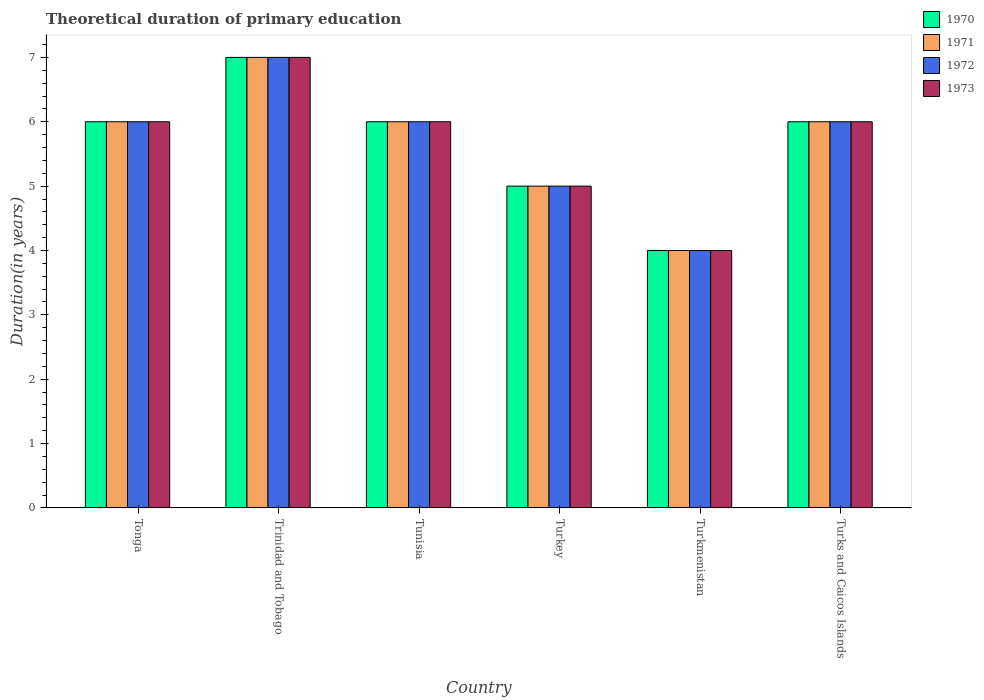How many groups of bars are there?
Ensure brevity in your answer.  6. Are the number of bars per tick equal to the number of legend labels?
Offer a very short reply. Yes. How many bars are there on the 1st tick from the left?
Keep it short and to the point. 4. How many bars are there on the 1st tick from the right?
Provide a short and direct response. 4. What is the label of the 1st group of bars from the left?
Your answer should be compact. Tonga. What is the total theoretical duration of primary education in 1970 in Trinidad and Tobago?
Give a very brief answer. 7. In which country was the total theoretical duration of primary education in 1971 maximum?
Your answer should be compact. Trinidad and Tobago. In which country was the total theoretical duration of primary education in 1971 minimum?
Offer a terse response. Turkmenistan. What is the total total theoretical duration of primary education in 1971 in the graph?
Ensure brevity in your answer.  34. What is the average total theoretical duration of primary education in 1971 per country?
Offer a terse response. 5.67. Is the total theoretical duration of primary education in 1971 in Tunisia less than that in Turks and Caicos Islands?
Provide a short and direct response. No. Is the difference between the total theoretical duration of primary education in 1973 in Trinidad and Tobago and Turkmenistan greater than the difference between the total theoretical duration of primary education in 1971 in Trinidad and Tobago and Turkmenistan?
Your answer should be compact. No. What is the difference between the highest and the second highest total theoretical duration of primary education in 1973?
Keep it short and to the point. -1. What is the difference between the highest and the lowest total theoretical duration of primary education in 1970?
Your answer should be very brief. 3. In how many countries, is the total theoretical duration of primary education in 1972 greater than the average total theoretical duration of primary education in 1972 taken over all countries?
Your answer should be compact. 4. What does the 2nd bar from the left in Tonga represents?
Provide a short and direct response. 1971. What does the 4th bar from the right in Turkey represents?
Give a very brief answer. 1970. Is it the case that in every country, the sum of the total theoretical duration of primary education in 1973 and total theoretical duration of primary education in 1972 is greater than the total theoretical duration of primary education in 1970?
Keep it short and to the point. Yes. How many bars are there?
Your response must be concise. 24. Does the graph contain any zero values?
Give a very brief answer. No. Does the graph contain grids?
Your answer should be very brief. No. How are the legend labels stacked?
Make the answer very short. Vertical. What is the title of the graph?
Make the answer very short. Theoretical duration of primary education. What is the label or title of the Y-axis?
Your response must be concise. Duration(in years). What is the Duration(in years) in 1972 in Tonga?
Provide a short and direct response. 6. What is the Duration(in years) in 1973 in Tonga?
Your answer should be very brief. 6. What is the Duration(in years) in 1970 in Trinidad and Tobago?
Give a very brief answer. 7. What is the Duration(in years) of 1971 in Trinidad and Tobago?
Ensure brevity in your answer.  7. What is the Duration(in years) in 1973 in Trinidad and Tobago?
Your answer should be compact. 7. What is the Duration(in years) in 1970 in Tunisia?
Your response must be concise. 6. What is the Duration(in years) of 1971 in Turkey?
Provide a short and direct response. 5. What is the Duration(in years) of 1972 in Turkey?
Your answer should be very brief. 5. What is the Duration(in years) of 1973 in Turkey?
Your answer should be very brief. 5. What is the Duration(in years) of 1971 in Turkmenistan?
Offer a very short reply. 4. What is the Duration(in years) in 1972 in Turkmenistan?
Your answer should be very brief. 4. What is the Duration(in years) in 1973 in Turkmenistan?
Provide a succinct answer. 4. What is the Duration(in years) in 1971 in Turks and Caicos Islands?
Give a very brief answer. 6. What is the Duration(in years) of 1973 in Turks and Caicos Islands?
Make the answer very short. 6. Across all countries, what is the maximum Duration(in years) of 1970?
Keep it short and to the point. 7. Across all countries, what is the maximum Duration(in years) of 1971?
Provide a short and direct response. 7. Across all countries, what is the minimum Duration(in years) in 1970?
Offer a very short reply. 4. Across all countries, what is the minimum Duration(in years) in 1972?
Your answer should be compact. 4. What is the total Duration(in years) of 1970 in the graph?
Provide a succinct answer. 34. What is the difference between the Duration(in years) of 1970 in Tonga and that in Trinidad and Tobago?
Provide a short and direct response. -1. What is the difference between the Duration(in years) of 1972 in Tonga and that in Trinidad and Tobago?
Keep it short and to the point. -1. What is the difference between the Duration(in years) in 1973 in Tonga and that in Trinidad and Tobago?
Your answer should be compact. -1. What is the difference between the Duration(in years) in 1970 in Tonga and that in Tunisia?
Provide a short and direct response. 0. What is the difference between the Duration(in years) in 1972 in Tonga and that in Tunisia?
Provide a short and direct response. 0. What is the difference between the Duration(in years) of 1973 in Tonga and that in Tunisia?
Give a very brief answer. 0. What is the difference between the Duration(in years) in 1970 in Tonga and that in Turkey?
Give a very brief answer. 1. What is the difference between the Duration(in years) of 1973 in Tonga and that in Turkmenistan?
Your answer should be very brief. 2. What is the difference between the Duration(in years) of 1970 in Tonga and that in Turks and Caicos Islands?
Make the answer very short. 0. What is the difference between the Duration(in years) of 1971 in Tonga and that in Turks and Caicos Islands?
Your response must be concise. 0. What is the difference between the Duration(in years) in 1973 in Tonga and that in Turks and Caicos Islands?
Your answer should be very brief. 0. What is the difference between the Duration(in years) of 1970 in Trinidad and Tobago and that in Tunisia?
Your response must be concise. 1. What is the difference between the Duration(in years) of 1970 in Trinidad and Tobago and that in Turkey?
Offer a terse response. 2. What is the difference between the Duration(in years) of 1971 in Trinidad and Tobago and that in Turkey?
Offer a very short reply. 2. What is the difference between the Duration(in years) of 1972 in Trinidad and Tobago and that in Turkey?
Keep it short and to the point. 2. What is the difference between the Duration(in years) of 1973 in Trinidad and Tobago and that in Turkey?
Offer a terse response. 2. What is the difference between the Duration(in years) of 1970 in Trinidad and Tobago and that in Turkmenistan?
Your answer should be very brief. 3. What is the difference between the Duration(in years) in 1972 in Trinidad and Tobago and that in Turkmenistan?
Ensure brevity in your answer.  3. What is the difference between the Duration(in years) in 1973 in Trinidad and Tobago and that in Turkmenistan?
Provide a short and direct response. 3. What is the difference between the Duration(in years) in 1970 in Trinidad and Tobago and that in Turks and Caicos Islands?
Make the answer very short. 1. What is the difference between the Duration(in years) in 1973 in Trinidad and Tobago and that in Turks and Caicos Islands?
Give a very brief answer. 1. What is the difference between the Duration(in years) in 1970 in Tunisia and that in Turkey?
Your answer should be very brief. 1. What is the difference between the Duration(in years) in 1972 in Tunisia and that in Turkey?
Give a very brief answer. 1. What is the difference between the Duration(in years) in 1970 in Tunisia and that in Turkmenistan?
Your response must be concise. 2. What is the difference between the Duration(in years) in 1972 in Tunisia and that in Turkmenistan?
Keep it short and to the point. 2. What is the difference between the Duration(in years) in 1970 in Tunisia and that in Turks and Caicos Islands?
Provide a short and direct response. 0. What is the difference between the Duration(in years) in 1972 in Tunisia and that in Turks and Caicos Islands?
Ensure brevity in your answer.  0. What is the difference between the Duration(in years) in 1973 in Tunisia and that in Turks and Caicos Islands?
Your response must be concise. 0. What is the difference between the Duration(in years) of 1972 in Turkey and that in Turkmenistan?
Offer a terse response. 1. What is the difference between the Duration(in years) of 1973 in Turkey and that in Turkmenistan?
Keep it short and to the point. 1. What is the difference between the Duration(in years) in 1972 in Turkey and that in Turks and Caicos Islands?
Ensure brevity in your answer.  -1. What is the difference between the Duration(in years) of 1970 in Turkmenistan and that in Turks and Caicos Islands?
Your answer should be compact. -2. What is the difference between the Duration(in years) in 1971 in Turkmenistan and that in Turks and Caicos Islands?
Keep it short and to the point. -2. What is the difference between the Duration(in years) of 1973 in Turkmenistan and that in Turks and Caicos Islands?
Provide a short and direct response. -2. What is the difference between the Duration(in years) in 1971 in Tonga and the Duration(in years) in 1972 in Trinidad and Tobago?
Offer a very short reply. -1. What is the difference between the Duration(in years) of 1972 in Tonga and the Duration(in years) of 1973 in Trinidad and Tobago?
Provide a short and direct response. -1. What is the difference between the Duration(in years) in 1971 in Tonga and the Duration(in years) in 1972 in Tunisia?
Provide a short and direct response. 0. What is the difference between the Duration(in years) in 1971 in Tonga and the Duration(in years) in 1973 in Tunisia?
Your answer should be compact. 0. What is the difference between the Duration(in years) of 1970 in Tonga and the Duration(in years) of 1973 in Turkey?
Make the answer very short. 1. What is the difference between the Duration(in years) of 1971 in Tonga and the Duration(in years) of 1972 in Turkey?
Keep it short and to the point. 1. What is the difference between the Duration(in years) in 1971 in Tonga and the Duration(in years) in 1973 in Turkey?
Keep it short and to the point. 1. What is the difference between the Duration(in years) in 1972 in Tonga and the Duration(in years) in 1973 in Turkey?
Offer a very short reply. 1. What is the difference between the Duration(in years) in 1971 in Tonga and the Duration(in years) in 1973 in Turks and Caicos Islands?
Provide a short and direct response. 0. What is the difference between the Duration(in years) in 1970 in Trinidad and Tobago and the Duration(in years) in 1973 in Tunisia?
Make the answer very short. 1. What is the difference between the Duration(in years) of 1971 in Trinidad and Tobago and the Duration(in years) of 1972 in Tunisia?
Give a very brief answer. 1. What is the difference between the Duration(in years) in 1971 in Trinidad and Tobago and the Duration(in years) in 1973 in Tunisia?
Offer a very short reply. 1. What is the difference between the Duration(in years) in 1970 in Trinidad and Tobago and the Duration(in years) in 1972 in Turkey?
Give a very brief answer. 2. What is the difference between the Duration(in years) in 1971 in Trinidad and Tobago and the Duration(in years) in 1972 in Turkey?
Your answer should be very brief. 2. What is the difference between the Duration(in years) of 1972 in Trinidad and Tobago and the Duration(in years) of 1973 in Turkey?
Ensure brevity in your answer.  2. What is the difference between the Duration(in years) of 1970 in Trinidad and Tobago and the Duration(in years) of 1973 in Turkmenistan?
Your response must be concise. 3. What is the difference between the Duration(in years) in 1972 in Trinidad and Tobago and the Duration(in years) in 1973 in Turkmenistan?
Provide a succinct answer. 3. What is the difference between the Duration(in years) in 1970 in Trinidad and Tobago and the Duration(in years) in 1971 in Turks and Caicos Islands?
Give a very brief answer. 1. What is the difference between the Duration(in years) of 1970 in Trinidad and Tobago and the Duration(in years) of 1972 in Turks and Caicos Islands?
Ensure brevity in your answer.  1. What is the difference between the Duration(in years) in 1970 in Trinidad and Tobago and the Duration(in years) in 1973 in Turks and Caicos Islands?
Your answer should be very brief. 1. What is the difference between the Duration(in years) in 1971 in Trinidad and Tobago and the Duration(in years) in 1973 in Turks and Caicos Islands?
Provide a succinct answer. 1. What is the difference between the Duration(in years) in 1972 in Trinidad and Tobago and the Duration(in years) in 1973 in Turks and Caicos Islands?
Provide a succinct answer. 1. What is the difference between the Duration(in years) in 1970 in Tunisia and the Duration(in years) in 1972 in Turkey?
Your answer should be compact. 1. What is the difference between the Duration(in years) of 1970 in Tunisia and the Duration(in years) of 1973 in Turkey?
Offer a terse response. 1. What is the difference between the Duration(in years) in 1971 in Tunisia and the Duration(in years) in 1972 in Turkey?
Provide a short and direct response. 1. What is the difference between the Duration(in years) in 1972 in Tunisia and the Duration(in years) in 1973 in Turkey?
Make the answer very short. 1. What is the difference between the Duration(in years) of 1970 in Tunisia and the Duration(in years) of 1971 in Turkmenistan?
Provide a succinct answer. 2. What is the difference between the Duration(in years) of 1971 in Tunisia and the Duration(in years) of 1972 in Turkmenistan?
Give a very brief answer. 2. What is the difference between the Duration(in years) in 1972 in Tunisia and the Duration(in years) in 1973 in Turkmenistan?
Your answer should be very brief. 2. What is the difference between the Duration(in years) of 1970 in Tunisia and the Duration(in years) of 1971 in Turks and Caicos Islands?
Your answer should be very brief. 0. What is the difference between the Duration(in years) of 1970 in Tunisia and the Duration(in years) of 1972 in Turks and Caicos Islands?
Offer a very short reply. 0. What is the difference between the Duration(in years) of 1971 in Tunisia and the Duration(in years) of 1972 in Turks and Caicos Islands?
Offer a terse response. 0. What is the difference between the Duration(in years) in 1971 in Tunisia and the Duration(in years) in 1973 in Turks and Caicos Islands?
Give a very brief answer. 0. What is the difference between the Duration(in years) of 1970 in Turkey and the Duration(in years) of 1971 in Turkmenistan?
Your answer should be very brief. 1. What is the difference between the Duration(in years) in 1970 in Turkey and the Duration(in years) in 1972 in Turkmenistan?
Offer a very short reply. 1. What is the difference between the Duration(in years) in 1970 in Turkey and the Duration(in years) in 1973 in Turkmenistan?
Your answer should be very brief. 1. What is the difference between the Duration(in years) in 1972 in Turkey and the Duration(in years) in 1973 in Turkmenistan?
Your answer should be compact. 1. What is the difference between the Duration(in years) in 1970 in Turkey and the Duration(in years) in 1972 in Turks and Caicos Islands?
Your answer should be compact. -1. What is the difference between the Duration(in years) of 1970 in Turkey and the Duration(in years) of 1973 in Turks and Caicos Islands?
Provide a short and direct response. -1. What is the difference between the Duration(in years) of 1970 in Turkmenistan and the Duration(in years) of 1971 in Turks and Caicos Islands?
Offer a very short reply. -2. What is the difference between the Duration(in years) in 1972 in Turkmenistan and the Duration(in years) in 1973 in Turks and Caicos Islands?
Make the answer very short. -2. What is the average Duration(in years) in 1970 per country?
Ensure brevity in your answer.  5.67. What is the average Duration(in years) in 1971 per country?
Provide a succinct answer. 5.67. What is the average Duration(in years) of 1972 per country?
Your response must be concise. 5.67. What is the average Duration(in years) in 1973 per country?
Provide a short and direct response. 5.67. What is the difference between the Duration(in years) in 1970 and Duration(in years) in 1971 in Tonga?
Provide a short and direct response. 0. What is the difference between the Duration(in years) in 1970 and Duration(in years) in 1972 in Tonga?
Offer a very short reply. 0. What is the difference between the Duration(in years) in 1971 and Duration(in years) in 1973 in Tonga?
Keep it short and to the point. 0. What is the difference between the Duration(in years) of 1972 and Duration(in years) of 1973 in Tonga?
Offer a terse response. 0. What is the difference between the Duration(in years) in 1971 and Duration(in years) in 1972 in Trinidad and Tobago?
Provide a short and direct response. 0. What is the difference between the Duration(in years) of 1971 and Duration(in years) of 1973 in Trinidad and Tobago?
Your answer should be very brief. 0. What is the difference between the Duration(in years) in 1972 and Duration(in years) in 1973 in Trinidad and Tobago?
Your answer should be very brief. 0. What is the difference between the Duration(in years) in 1970 and Duration(in years) in 1972 in Tunisia?
Offer a terse response. 0. What is the difference between the Duration(in years) of 1970 and Duration(in years) of 1973 in Tunisia?
Keep it short and to the point. 0. What is the difference between the Duration(in years) in 1971 and Duration(in years) in 1973 in Tunisia?
Your answer should be compact. 0. What is the difference between the Duration(in years) in 1972 and Duration(in years) in 1973 in Tunisia?
Provide a short and direct response. 0. What is the difference between the Duration(in years) in 1970 and Duration(in years) in 1971 in Turkey?
Your response must be concise. 0. What is the difference between the Duration(in years) in 1970 and Duration(in years) in 1973 in Turkey?
Offer a very short reply. 0. What is the difference between the Duration(in years) of 1972 and Duration(in years) of 1973 in Turkey?
Provide a short and direct response. 0. What is the difference between the Duration(in years) of 1970 and Duration(in years) of 1972 in Turkmenistan?
Ensure brevity in your answer.  0. What is the difference between the Duration(in years) in 1970 and Duration(in years) in 1973 in Turkmenistan?
Your answer should be very brief. 0. What is the difference between the Duration(in years) in 1971 and Duration(in years) in 1972 in Turkmenistan?
Your answer should be very brief. 0. What is the difference between the Duration(in years) of 1971 and Duration(in years) of 1973 in Turkmenistan?
Offer a terse response. 0. What is the difference between the Duration(in years) in 1972 and Duration(in years) in 1973 in Turkmenistan?
Provide a short and direct response. 0. What is the difference between the Duration(in years) in 1970 and Duration(in years) in 1971 in Turks and Caicos Islands?
Ensure brevity in your answer.  0. What is the difference between the Duration(in years) of 1971 and Duration(in years) of 1973 in Turks and Caicos Islands?
Offer a very short reply. 0. What is the difference between the Duration(in years) in 1972 and Duration(in years) in 1973 in Turks and Caicos Islands?
Your answer should be compact. 0. What is the ratio of the Duration(in years) of 1971 in Tonga to that in Trinidad and Tobago?
Offer a very short reply. 0.86. What is the ratio of the Duration(in years) in 1973 in Tonga to that in Trinidad and Tobago?
Your answer should be compact. 0.86. What is the ratio of the Duration(in years) in 1970 in Tonga to that in Tunisia?
Offer a very short reply. 1. What is the ratio of the Duration(in years) in 1972 in Tonga to that in Tunisia?
Provide a short and direct response. 1. What is the ratio of the Duration(in years) of 1973 in Tonga to that in Tunisia?
Offer a terse response. 1. What is the ratio of the Duration(in years) in 1970 in Tonga to that in Turkey?
Provide a short and direct response. 1.2. What is the ratio of the Duration(in years) in 1970 in Tonga to that in Turks and Caicos Islands?
Provide a succinct answer. 1. What is the ratio of the Duration(in years) of 1972 in Tonga to that in Turks and Caicos Islands?
Offer a terse response. 1. What is the ratio of the Duration(in years) in 1973 in Tonga to that in Turks and Caicos Islands?
Offer a terse response. 1. What is the ratio of the Duration(in years) in 1970 in Trinidad and Tobago to that in Tunisia?
Offer a terse response. 1.17. What is the ratio of the Duration(in years) of 1971 in Trinidad and Tobago to that in Tunisia?
Your answer should be compact. 1.17. What is the ratio of the Duration(in years) in 1970 in Trinidad and Tobago to that in Turkey?
Your answer should be compact. 1.4. What is the ratio of the Duration(in years) in 1972 in Trinidad and Tobago to that in Turkey?
Provide a short and direct response. 1.4. What is the ratio of the Duration(in years) of 1973 in Trinidad and Tobago to that in Turkey?
Your answer should be very brief. 1.4. What is the ratio of the Duration(in years) of 1971 in Trinidad and Tobago to that in Turkmenistan?
Keep it short and to the point. 1.75. What is the ratio of the Duration(in years) in 1972 in Trinidad and Tobago to that in Turkmenistan?
Give a very brief answer. 1.75. What is the ratio of the Duration(in years) of 1973 in Trinidad and Tobago to that in Turkmenistan?
Give a very brief answer. 1.75. What is the ratio of the Duration(in years) in 1970 in Trinidad and Tobago to that in Turks and Caicos Islands?
Provide a succinct answer. 1.17. What is the ratio of the Duration(in years) in 1973 in Trinidad and Tobago to that in Turks and Caicos Islands?
Make the answer very short. 1.17. What is the ratio of the Duration(in years) in 1970 in Tunisia to that in Turkey?
Offer a terse response. 1.2. What is the ratio of the Duration(in years) in 1972 in Tunisia to that in Turkey?
Keep it short and to the point. 1.2. What is the ratio of the Duration(in years) in 1973 in Tunisia to that in Turkey?
Make the answer very short. 1.2. What is the ratio of the Duration(in years) in 1970 in Tunisia to that in Turkmenistan?
Your answer should be compact. 1.5. What is the ratio of the Duration(in years) in 1970 in Tunisia to that in Turks and Caicos Islands?
Keep it short and to the point. 1. What is the ratio of the Duration(in years) in 1972 in Tunisia to that in Turks and Caicos Islands?
Ensure brevity in your answer.  1. What is the ratio of the Duration(in years) in 1973 in Tunisia to that in Turks and Caicos Islands?
Your response must be concise. 1. What is the ratio of the Duration(in years) in 1971 in Turkey to that in Turkmenistan?
Keep it short and to the point. 1.25. What is the ratio of the Duration(in years) in 1970 in Turkey to that in Turks and Caicos Islands?
Provide a succinct answer. 0.83. What is the ratio of the Duration(in years) in 1971 in Turkey to that in Turks and Caicos Islands?
Make the answer very short. 0.83. What is the ratio of the Duration(in years) of 1973 in Turkey to that in Turks and Caicos Islands?
Offer a very short reply. 0.83. What is the ratio of the Duration(in years) of 1973 in Turkmenistan to that in Turks and Caicos Islands?
Your answer should be compact. 0.67. What is the difference between the highest and the second highest Duration(in years) in 1972?
Provide a short and direct response. 1. What is the difference between the highest and the lowest Duration(in years) of 1970?
Make the answer very short. 3. What is the difference between the highest and the lowest Duration(in years) of 1972?
Provide a succinct answer. 3. What is the difference between the highest and the lowest Duration(in years) of 1973?
Provide a short and direct response. 3. 